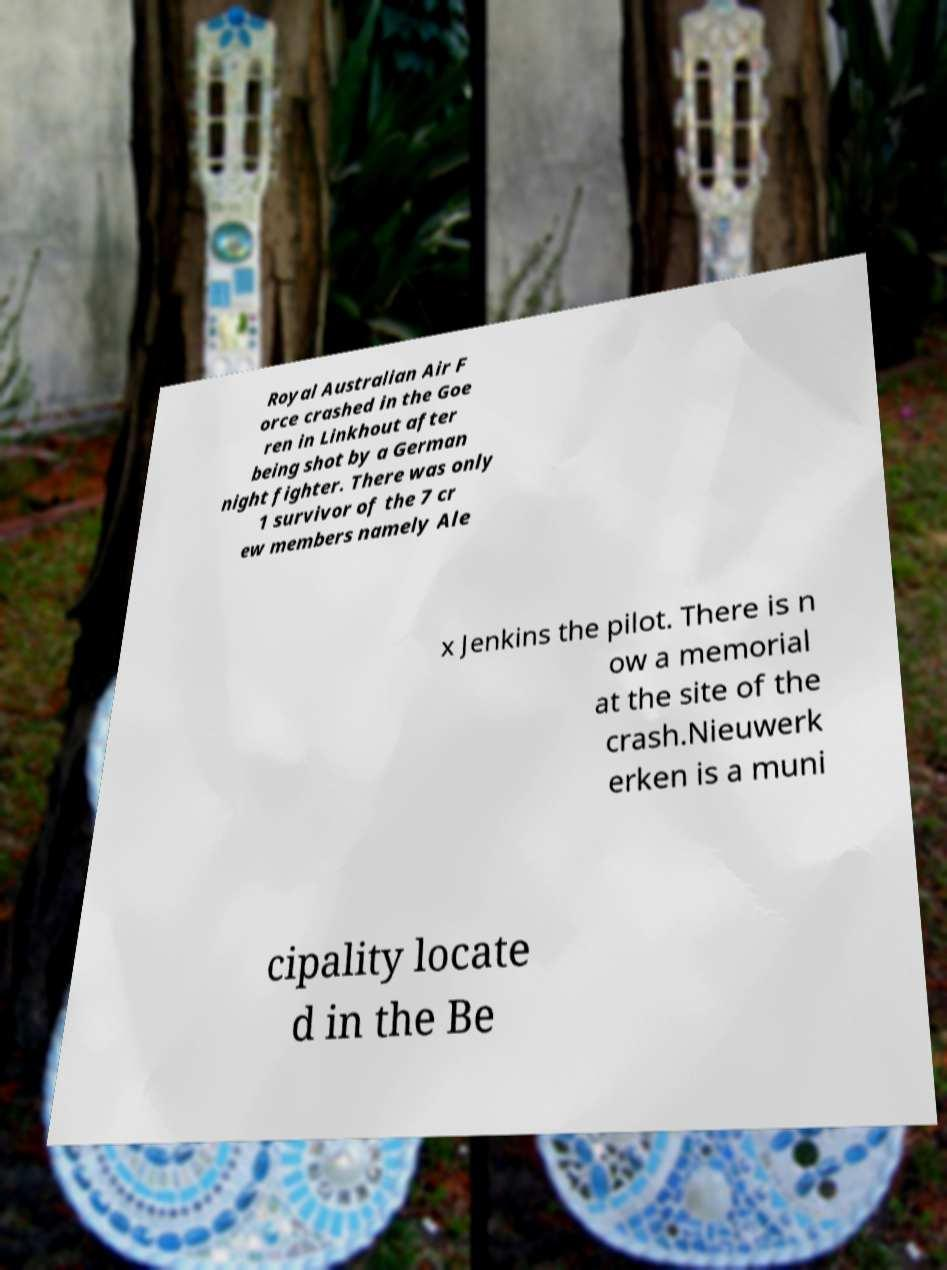For documentation purposes, I need the text within this image transcribed. Could you provide that? Royal Australian Air F orce crashed in the Goe ren in Linkhout after being shot by a German night fighter. There was only 1 survivor of the 7 cr ew members namely Ale x Jenkins the pilot. There is n ow a memorial at the site of the crash.Nieuwerk erken is a muni cipality locate d in the Be 